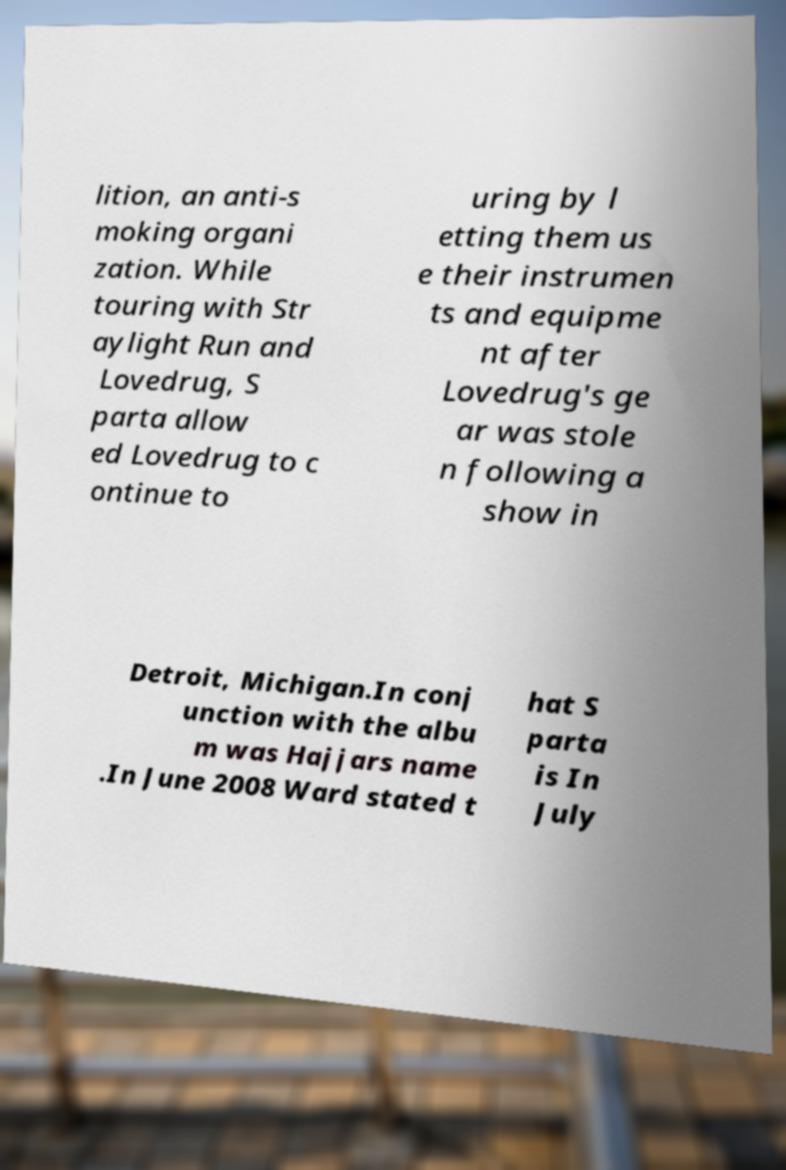Could you extract and type out the text from this image? lition, an anti-s moking organi zation. While touring with Str aylight Run and Lovedrug, S parta allow ed Lovedrug to c ontinue to uring by l etting them us e their instrumen ts and equipme nt after Lovedrug's ge ar was stole n following a show in Detroit, Michigan.In conj unction with the albu m was Hajjars name .In June 2008 Ward stated t hat S parta is In July 